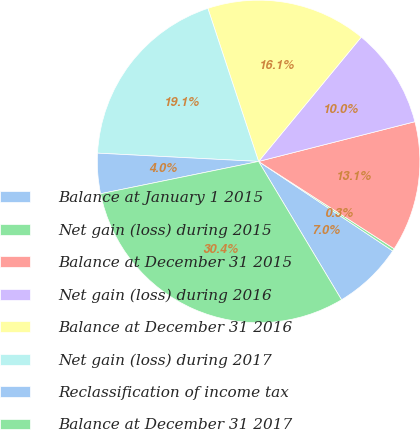Convert chart to OTSL. <chart><loc_0><loc_0><loc_500><loc_500><pie_chart><fcel>Balance at January 1 2015<fcel>Net gain (loss) during 2015<fcel>Balance at December 31 2015<fcel>Net gain (loss) during 2016<fcel>Balance at December 31 2016<fcel>Net gain (loss) during 2017<fcel>Reclassification of income tax<fcel>Balance at December 31 2017<nl><fcel>7.04%<fcel>0.26%<fcel>13.07%<fcel>10.05%<fcel>16.08%<fcel>19.09%<fcel>4.03%<fcel>30.39%<nl></chart> 